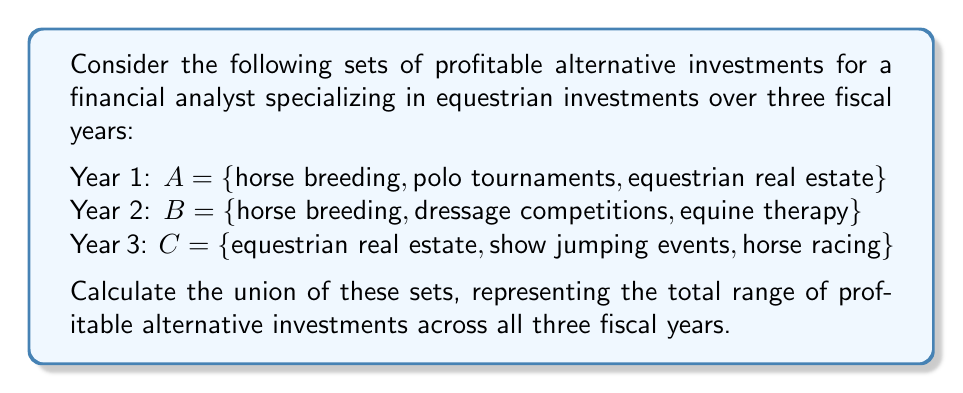Could you help me with this problem? To solve this problem, we need to find the union of sets A, B, and C. The union of sets includes all unique elements from all sets, without repetition.

Let's follow these steps:

1. List all elements from set A:
   $\{$horse breeding, polo tournaments, equestrian real estate$\}$

2. Add unique elements from set B:
   $\{$horse breeding, polo tournaments, equestrian real estate, dressage competitions, equine therapy$\}$
   
   Note: "horse breeding" is already included, so we don't add it again.

3. Add unique elements from set C:
   $\{$horse breeding, polo tournaments, equestrian real estate, dressage competitions, equine therapy, show jumping events, horse racing$\}$
   
   Note: "equestrian real estate" is already included, so we don't add it again.

4. The resulting set is the union of A, B, and C, which we can write as $A \cup B \cup C$.

In set notation, this can be expressed as:

$$A \cup B \cup C = \{x \mid x \in A \text{ or } x \in B \text{ or } x \in C\}$$

The union contains 7 unique profitable alternative investments across the three fiscal years.
Answer: $A \cup B \cup C = \{$horse breeding, polo tournaments, equestrian real estate, dressage competitions, equine therapy, show jumping events, horse racing$\}$ 